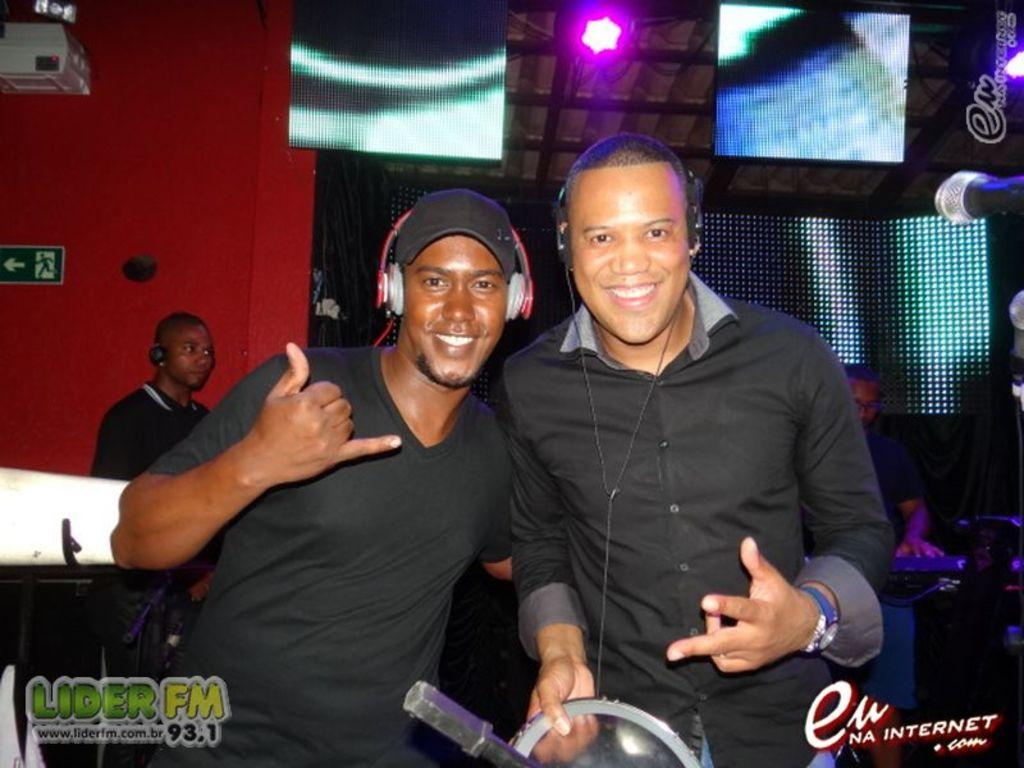How many people are present in the image? There are two people in the image. What are the two people wearing? The two people are wearing headphones. Are there any other people visible in the image? Yes, there is another person visible in the image. What can be seen on the wall in the image? There are lights on the wall. What type of can is being used by the person in the image? There is no can present in the image. What color is the balloon held by the person in the image? There is no balloon present in the image. 